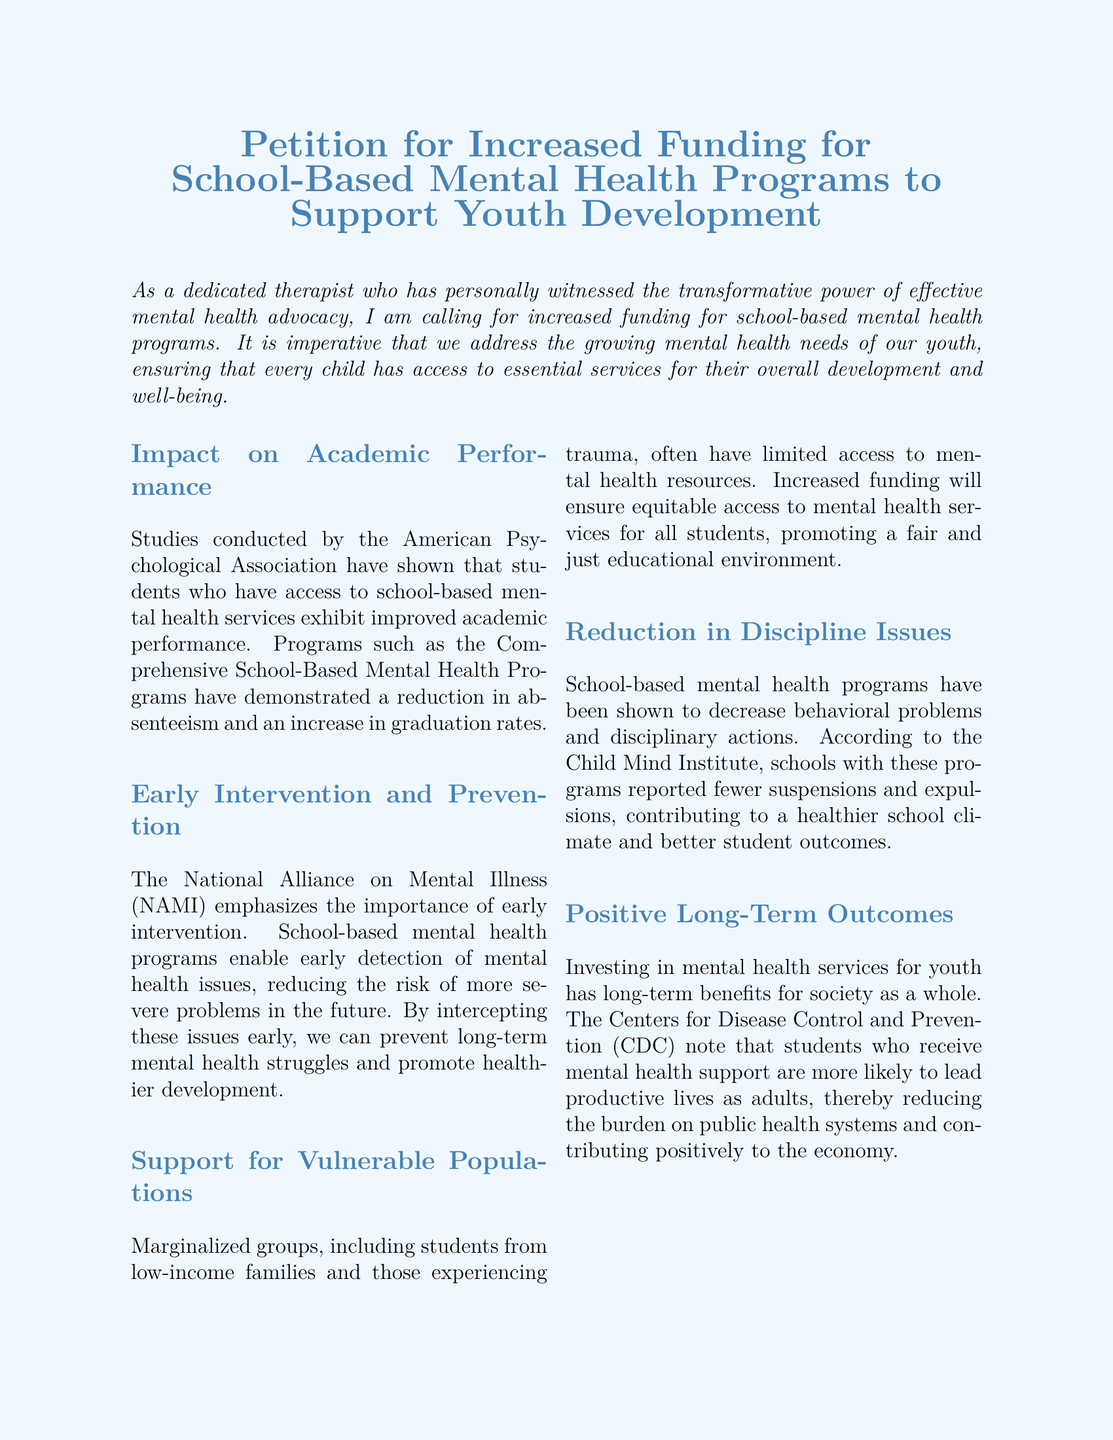What is the title of the petition? The title is directly stated at the top of the document, highlighting the main focus of the petition.
Answer: Petition for Increased Funding for School-Based Mental Health Programs to Support Youth Development Who conducted studies on the impact of school-based mental health services? The American Psychological Association is mentioned as the source of studies regarding academic performance improvements.
Answer: American Psychological Association What is emphasized by the National Alliance on Mental Illness regarding intervention? The document states that NAMI emphasizes the importance of early intervention in addressing mental health issues.
Answer: Early intervention Which marginalized groups are specifically mentioned in the petition? The document highlights students from low-income families and those experiencing trauma as vulnerable populations.
Answer: Students from low-income families and those experiencing trauma What effect do school-based mental health programs have on suspensions? The Child Mind Institute reports that schools with mental health programs saw a decrease in suspensions and expulsions.
Answer: Decrease in suspensions and expulsions What long-term benefit is noted by the Centers for Disease Control and Prevention? The CDC indicates that students who receive mental health support are more likely to lead productive lives as adults.
Answer: Productive lives as adults 